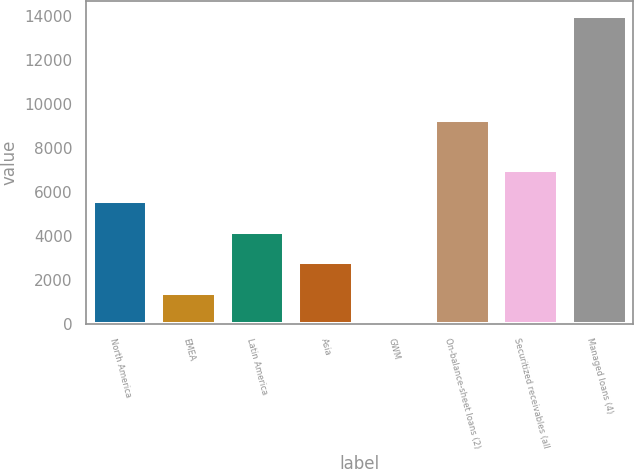<chart> <loc_0><loc_0><loc_500><loc_500><bar_chart><fcel>North America<fcel>EMEA<fcel>Latin America<fcel>Asia<fcel>GWM<fcel>On-balance-sheet loans (2)<fcel>Securitized receivables (all<fcel>Managed loans (4)<nl><fcel>5593.8<fcel>1399.2<fcel>4195.6<fcel>2797.4<fcel>1<fcel>9255<fcel>6992<fcel>13983<nl></chart> 